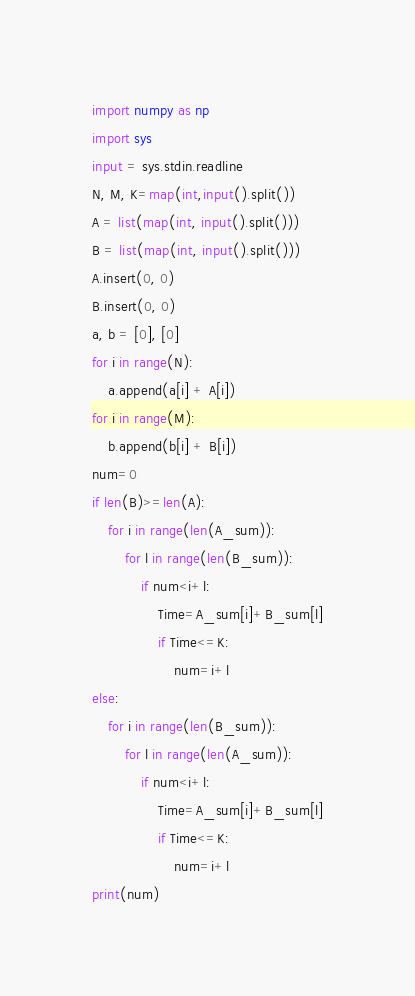Convert code to text. <code><loc_0><loc_0><loc_500><loc_500><_Python_>import numpy as np
import sys
input = sys.stdin.readline
N, M, K=map(int,input().split())
A = list(map(int, input().split()))
B = list(map(int, input().split()))
A.insert(0, 0)
B.insert(0, 0)
a, b = [0], [0]
for i in range(N):
    a.append(a[i] + A[i])
for i in range(M):
    b.append(b[i] + B[i])
num=0
if len(B)>=len(A):
    for i in range(len(A_sum)):
        for l in range(len(B_sum)):
            if num<i+l:
                Time=A_sum[i]+B_sum[l]
                if Time<=K:
                    num=i+l
else:
    for i in range(len(B_sum)):
        for l in range(len(A_sum)):
            if num<i+l:
                Time=A_sum[i]+B_sum[l]
                if Time<=K:
                    num=i+l 
print(num)</code> 